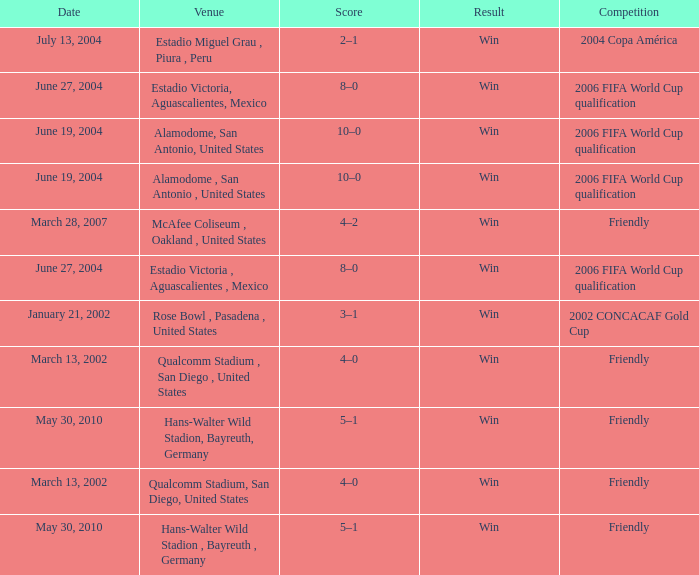What competition has June 19, 2004 as the date? 2006 FIFA World Cup qualification, 2006 FIFA World Cup qualification. 